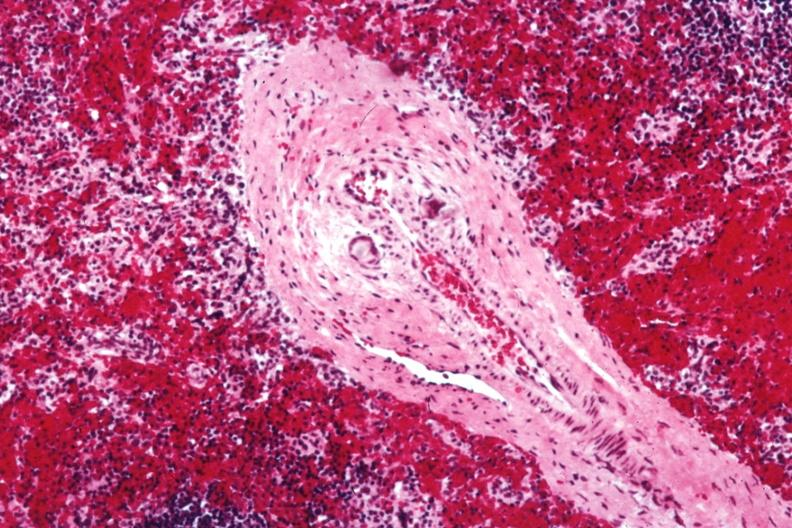s hematologic present?
Answer the question using a single word or phrase. Yes 